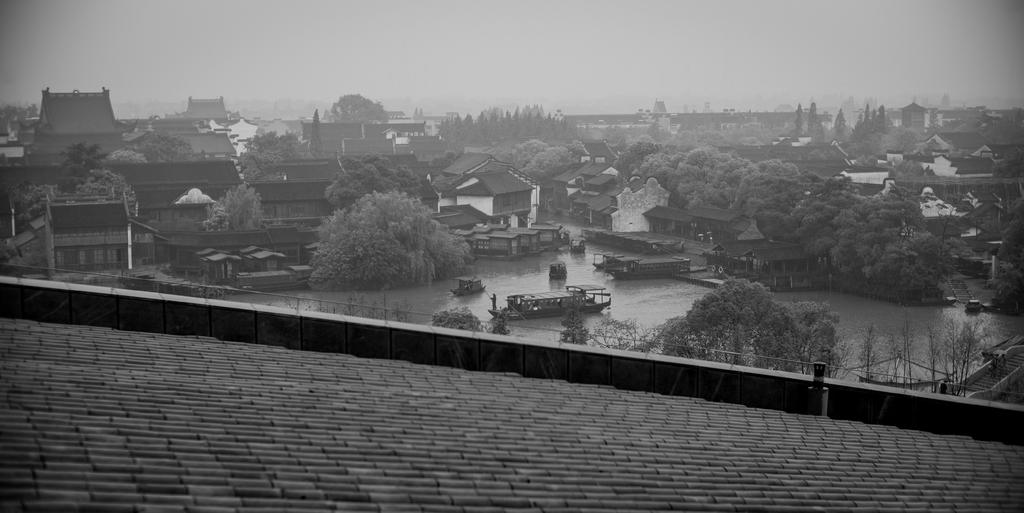What type of structures can be seen in the image? There are many houses in the image. What other natural elements are present in the image? There are trees in the image. What can be seen at the bottom of the image? There is water visible at the bottom of the image. What is floating on the water in the image? Boats are present in the water. What part of a building is visible in the front of the image? There is a roof visible in the front of the image. How does the plate twist in the image? There is no plate present in the image, so it cannot twist. 